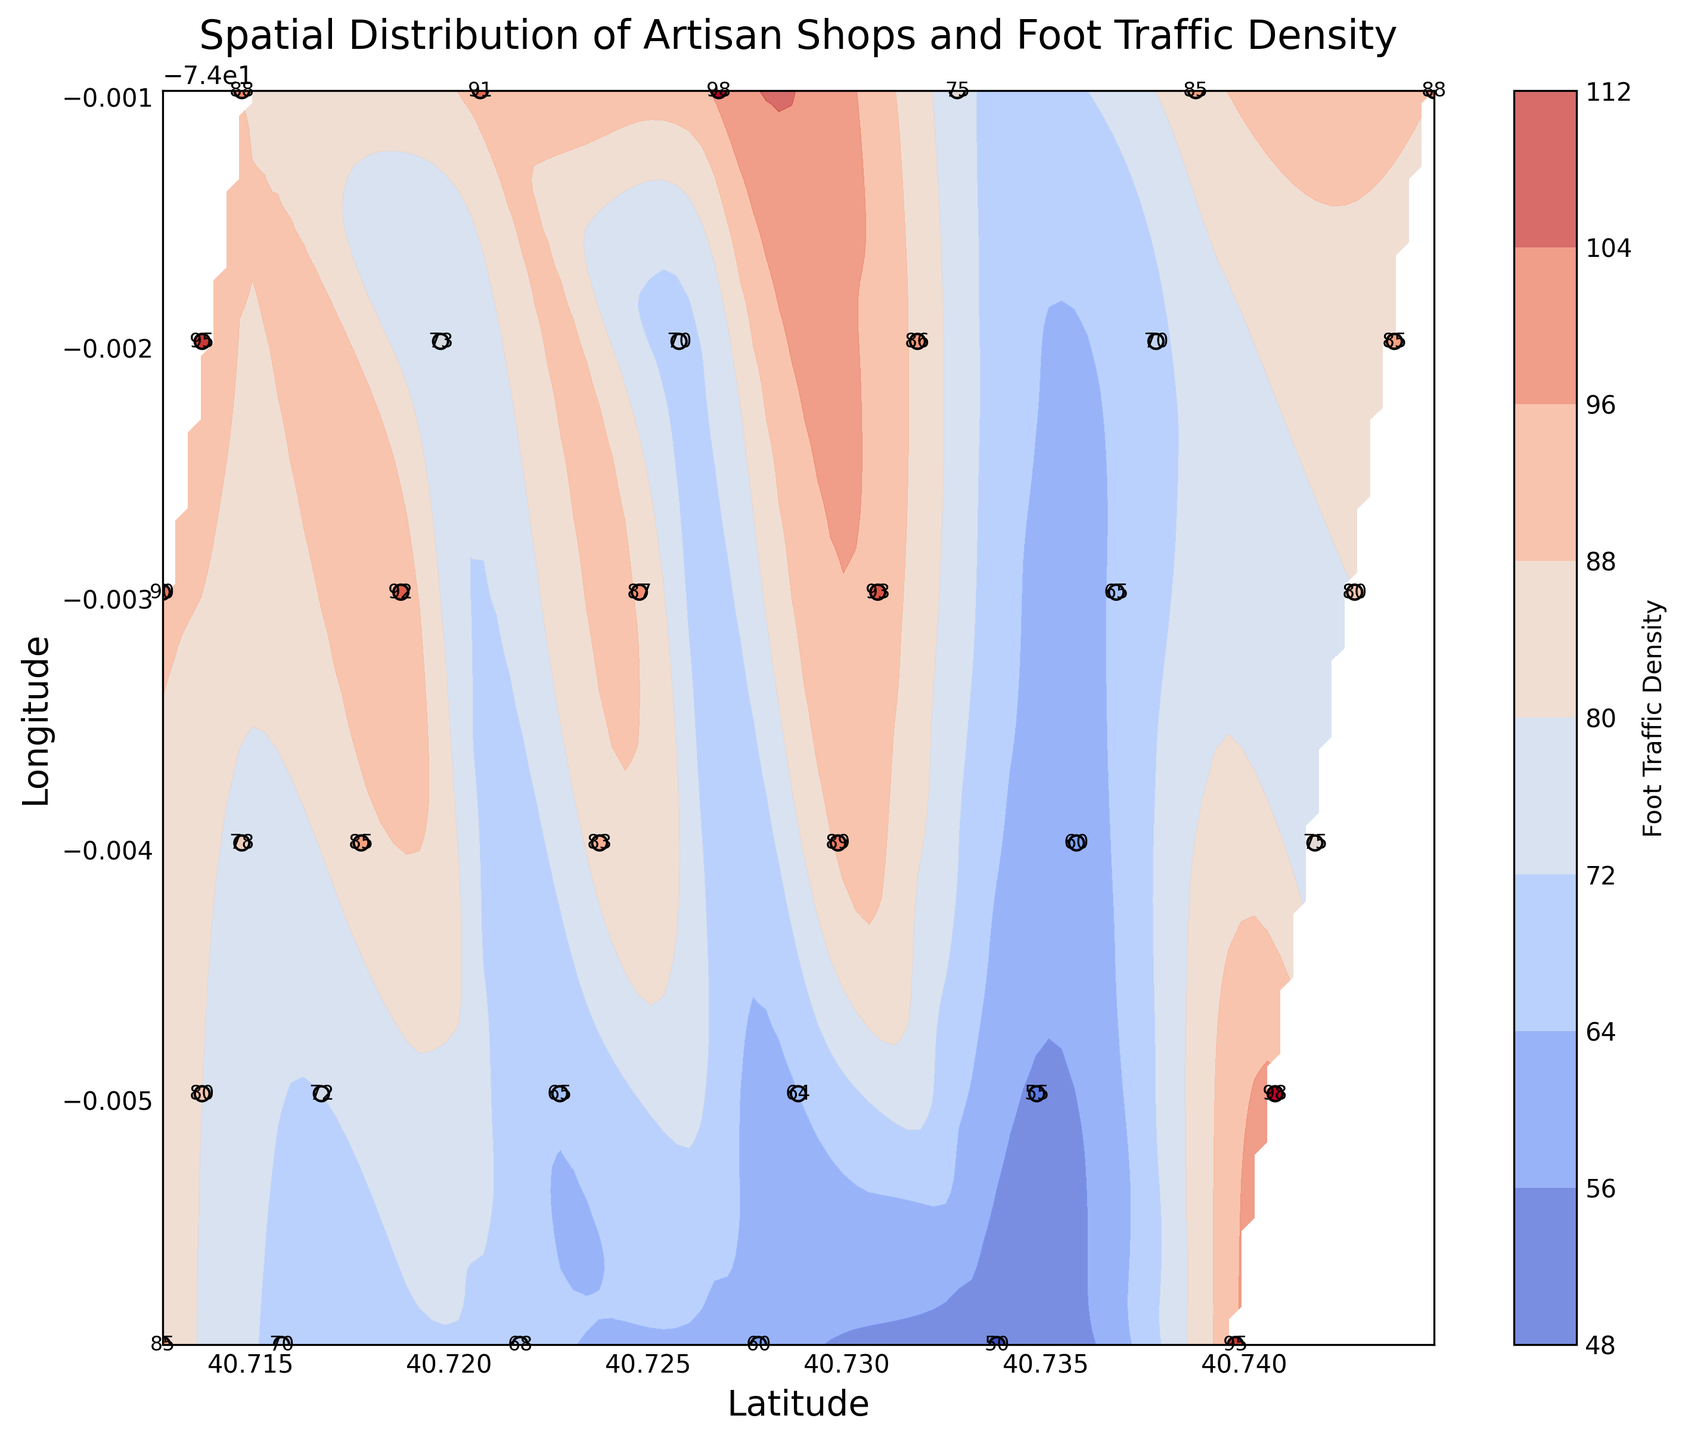Which latitude has the highest foot traffic density? To find the latitude with the highest foot traffic density, refer to the color intensity on the contour plot. The most intense color indicates the highest density. Looking at the color bar, find where the darkest color is located on the latitude axis.
Answer: 40.726776 What is the range of foot traffic values represented in the contour plot? The color bar on the right side of the contour plot displays the range of foot traffic density values. By checking the minimum and maximum values on the color bar, you can determine the range.
Answer: 50 to 98 Are artisan shops clustered in areas of high foot traffic density? Referring to the scatter points and the contour plot, observe if the dots (shops) are more concentrated where the contour colors indicate higher foot traffic density. Many shops are situated around the denser, more intensely colored areas.
Answer: Yes Which latitude has the lowest foot traffic density? By finding the lightest color on the contour plot and matching it to the latitude axis, you can determine which latitude corresponds to the lowest foot traffic density according to the color bar.
Answer: 40.733776 Compare the foot traffic at 40.739776 latitude with that at 40.726776 latitude. Which one is higher? Locate the dots at these specific latitudes and compare their foot traffic values, which are labeled next to each dot on the plot. Match the numeric values to see which one is higher.
Answer: 40.739776 What is the average foot traffic of the artisan shops located between longitudes -74.005974 and -74.004974? Find the dots between these longitudes and sum their foot traffic values. Then divide by the number of these dots to find the average.
Answer: 78.4 Which area (latitude and longitude range) shows the most even distribution of foot traffic density? Even distribution is indicated by smoother transition colors on the contour plot. Find areas where the contour lines are farther apart and more uniform without large gradients.
Answer: Around latitudes 40.734776 to 40.741776 and longitudes -74.004974 to -74.000974 Is there a noticeable trend in foot traffic density as latitude increases? Look at the contour colors as you move from the bottom to the top of the latitude axis. Note if the colors show a gradual increase or decrease in foot traffic density moving in this direction.
Answer: Yes, an increasing trend Compare the artifact shops at coordinates (40.712776, -74.002974) and (40.743776, -74.001974). Which shop has higher foot traffic? Check the labels next to the scatter points at these coordinates and compare the numeric foot traffic values.
Answer: (40.743776, -74.001974) What is the foot traffic density in the area where latitude is 40.720776 and longitude is -74.000974? Find the scatter point corresponding to these coordinates and read the labeled foot traffic value next to it.
Answer: 91 